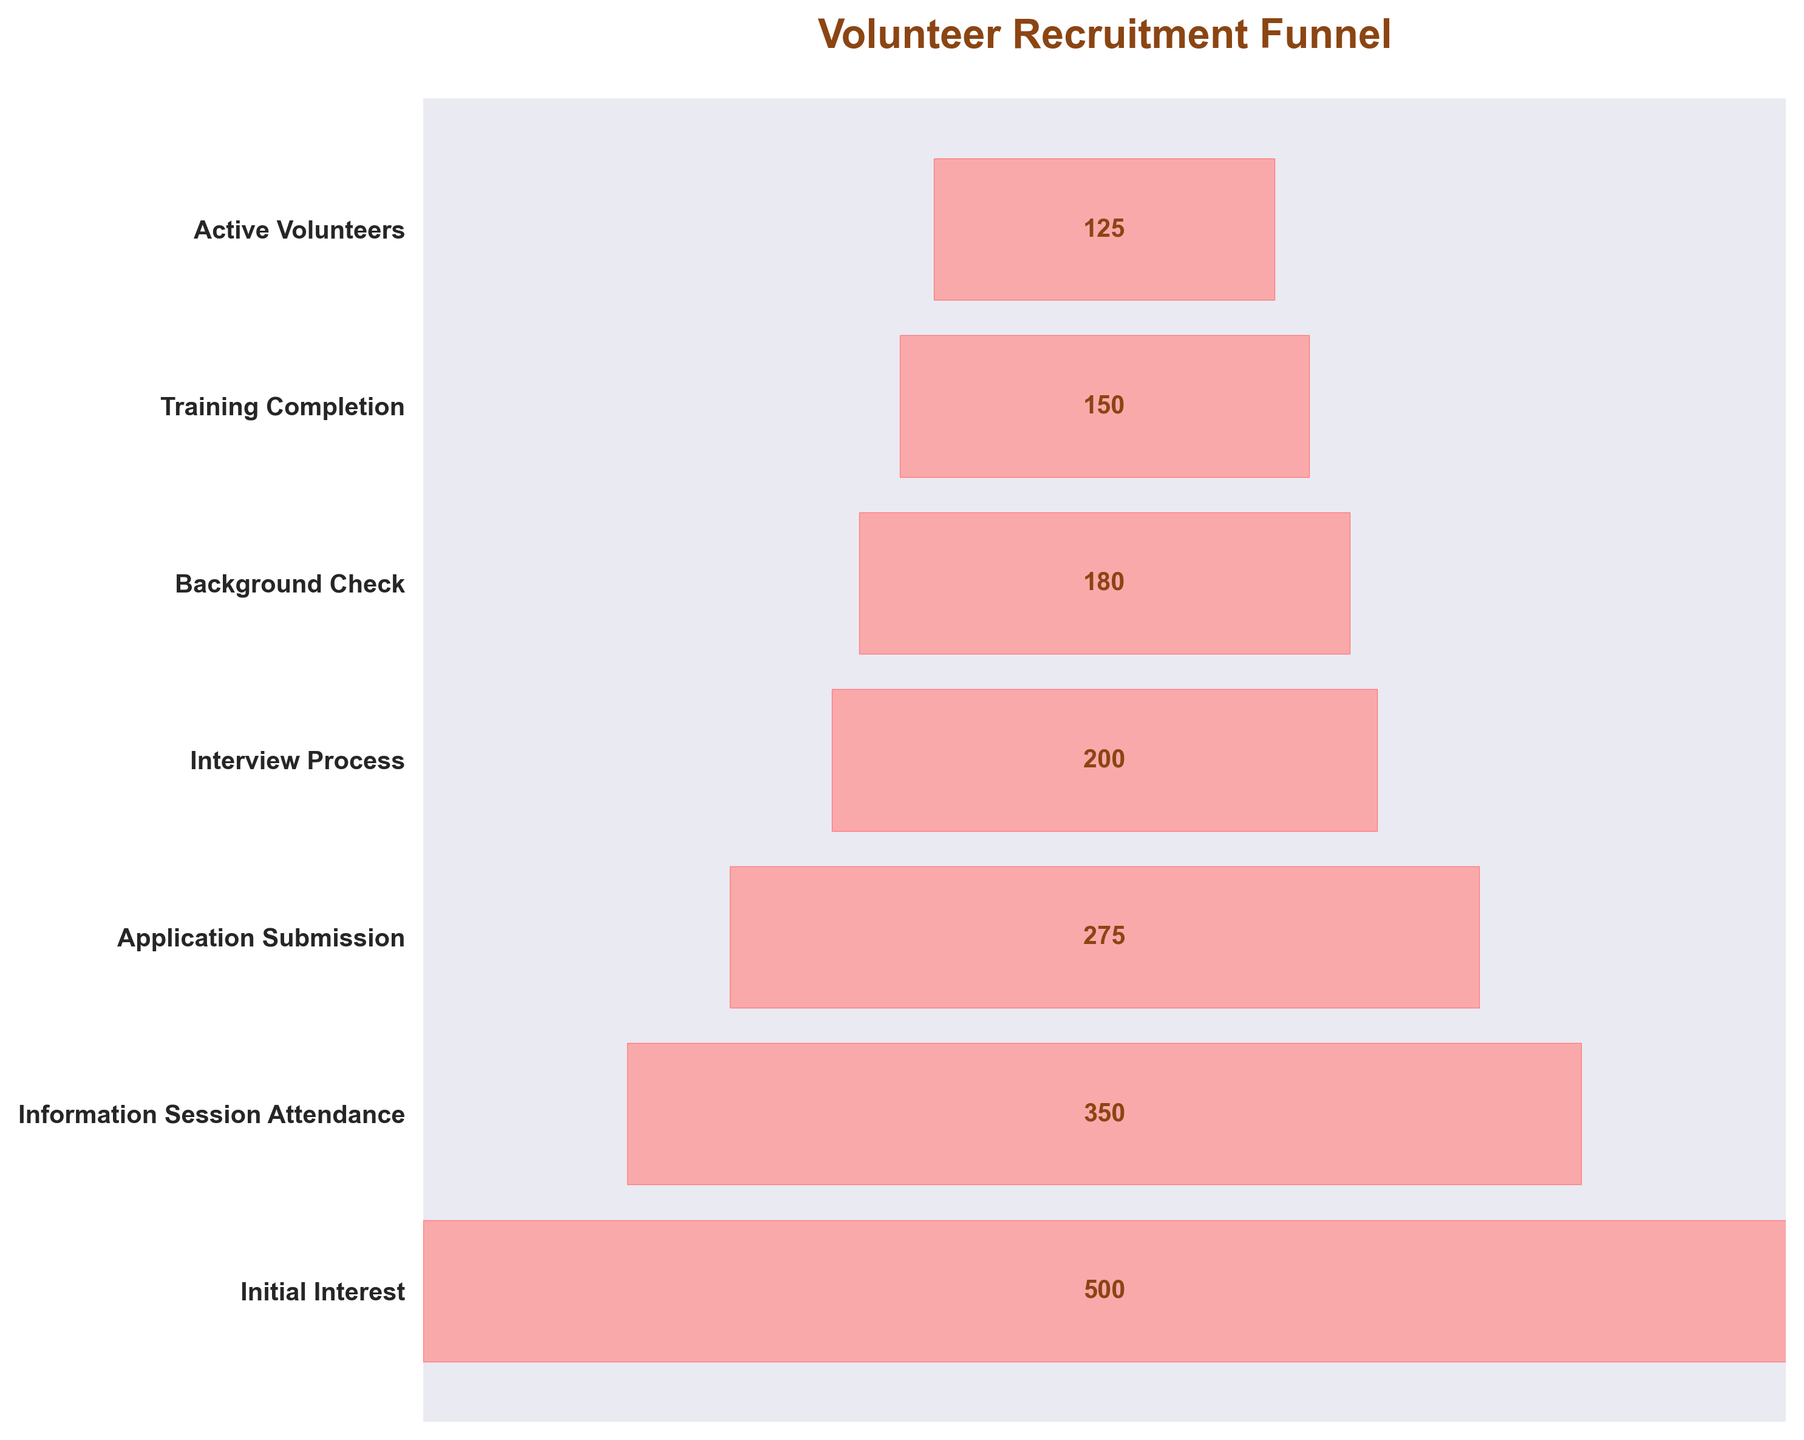What's the title of the chart? The title is positioned at the top of the chart, it reads 'Volunteer Recruitment Funnel'.
Answer: Volunteer Recruitment Funnel How many stages are there in the funnel? Count the number of y-ticks on the chart or the number of stages listed on the y-axis.
Answer: 7 What is the number of people at the initial interest stage? Look at the bar labeled 'Initial Interest' in the funnel chart and read the number inside the bar.
Answer: 500 Which stage has the fewest number of people? The shortest bar in the funnel chart represents the stage with the fewest people, which is 'Active Volunteers'.
Answer: Active Volunteers What percentage of people from the Information Session Attendance stage submit applications? Divide the number of application submissions by the number attending the information session and multiply by 100. 275/350 * 100 = 78.6%
Answer: 78.6% What is the drop-off in the number of people from the Interview Process to the Background Check stage? Subtract the number of people in the Background Check stage from the number in the Interview Process stage. 200 - 180 = 20
Answer: 20 How many people drop off from the Information Session Attendance stage to the Application Submission stage? Subtract the number in the Application Submission stage from the number in the Information Session Attendance stage. 350 - 275 = 75
Answer: 75 Is there a stage where less than half of the previous stage's people proceed? Compare each stage's number to see if it's less than half of the previous stage's number. No stage number is less than half of the previous stage's number.
Answer: No Compare the number of people in the Interview Process stage with those in the Training Completion stage, which has more and by how much? Subtract the number in the Training Completion stage from the number in the Interview Process stage and check which has more. 200 - 150 = 50 more people in the Interview Process stage.
Answer: Interview Process, 50 What is the difference in the number of people between the Background Check and Active Volunteers stages? Subtract the number in the Active Volunteers stage from the number in the Background Check stage. 180 - 125 = 55
Answer: 55 